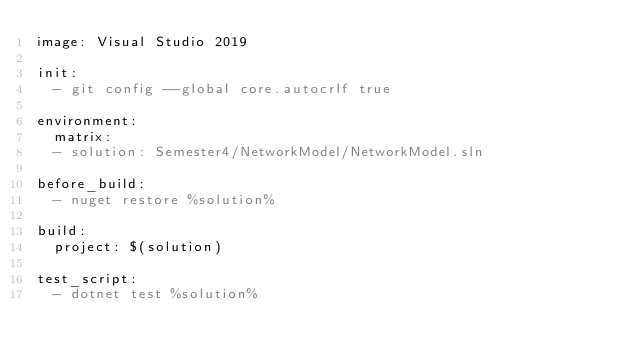Convert code to text. <code><loc_0><loc_0><loc_500><loc_500><_YAML_>image: Visual Studio 2019

init:
  - git config --global core.autocrlf true

environment:
  matrix:
  - solution: Semester4/NetworkModel/NetworkModel.sln

before_build:
  - nuget restore %solution%

build:
  project: $(solution)

test_script:
  - dotnet test %solution%
</code> 